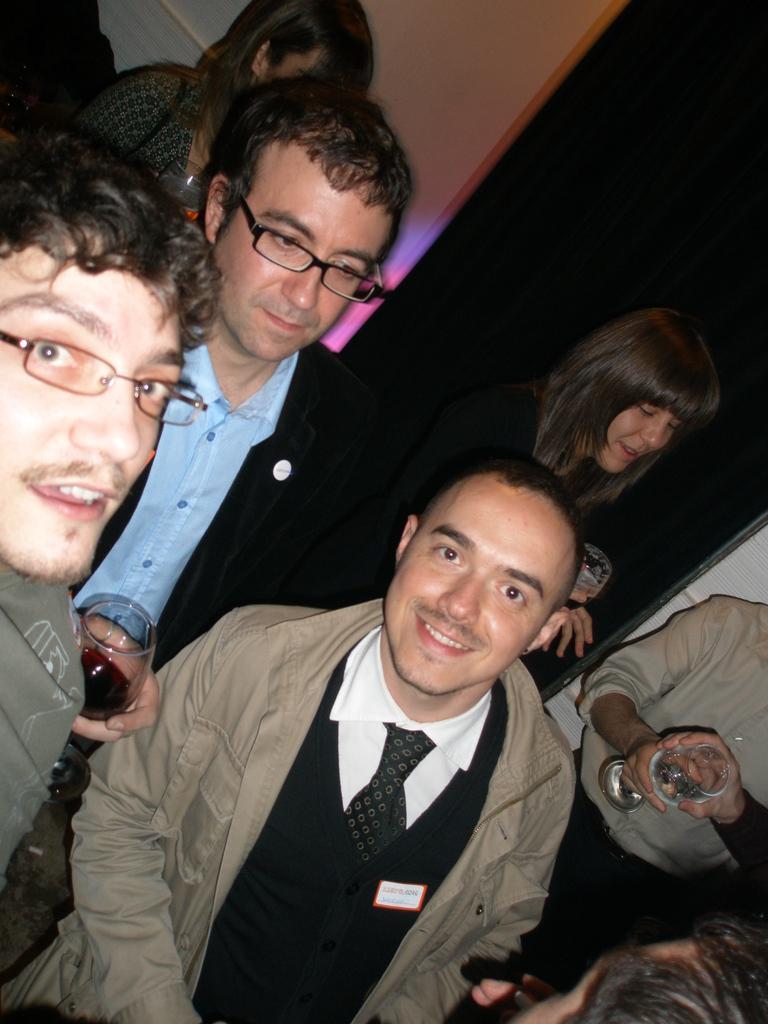In one or two sentences, can you explain what this image depicts? In this image I can see few people standing and wearing different color dresses. Few people are holding glasses. 